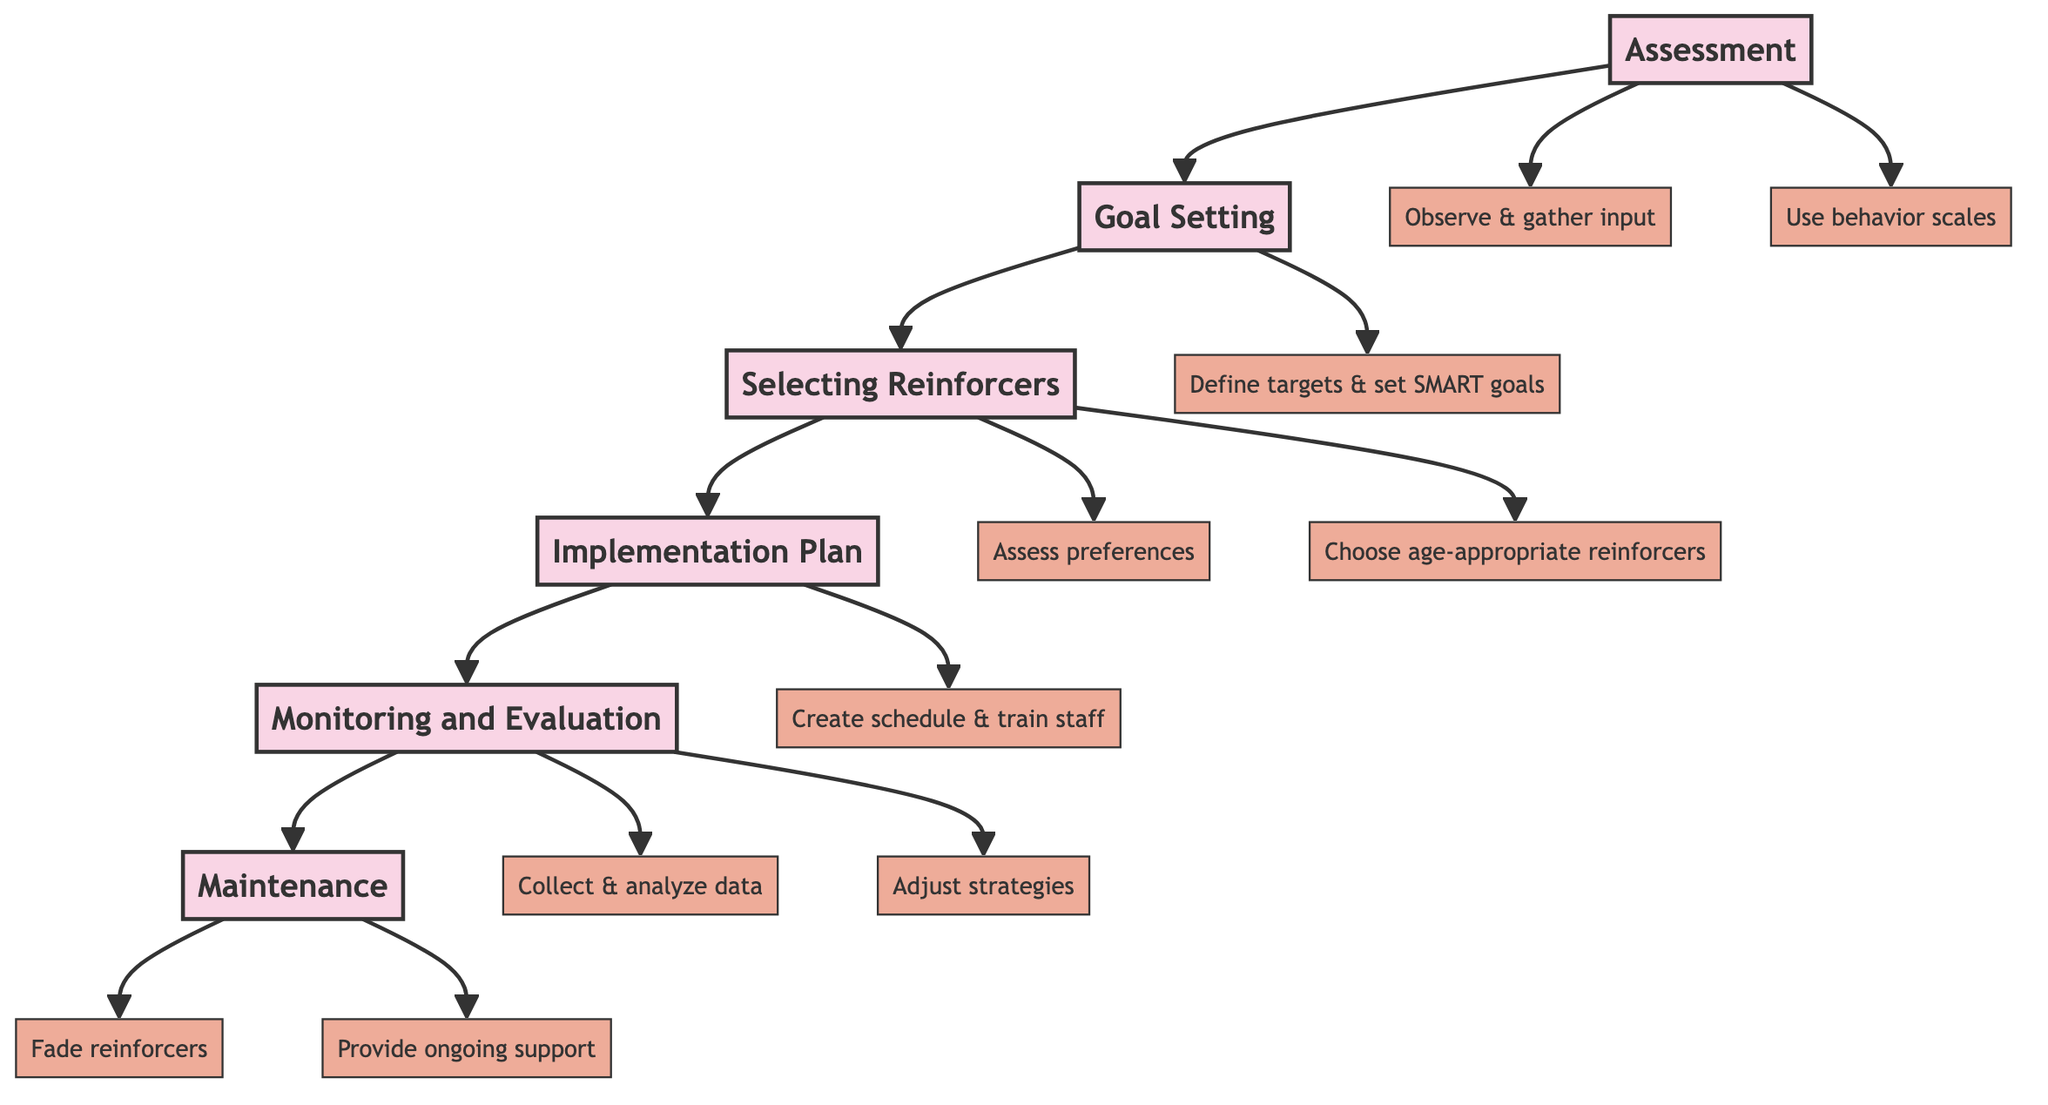What is the first step in the pathway? The diagram indicates that the first step in the sequence is "Assessment." This is the first node from which all subsequent steps branch off.
Answer: Assessment How many steps are there in total? By counting the nodes labeled as steps in the diagram, there are six distinct steps: Assessment, Goal Setting, Selecting Reinforcers, Implementation Plan, Monitoring and Evaluation, and Maintenance.
Answer: Six What is the last step of the clinical pathway? The sequence flows to the last node named "Maintenance," which signifies the endpoint of the pathway.
Answer: Maintenance Which step follows "Selecting Reinforcers"? The diagram shows that "Implementation Plan" is the next step that follows after "Selecting Reinforcers," forming a direct connection in the flow of the pathway.
Answer: Implementation Plan What actions are associated with "Goal Setting"? The key actions related to "Goal Setting" are defining target behaviors, setting short-term and long-term goals, and ensuring that the goals are SMART. This information can be derived from the detailed descriptions linked to that step.
Answer: Define targets, Set goals, Ensure SMART Explain the relationship between “Monitoring and Evaluation” and “Maintenance.” "Monitoring and Evaluation" precedes "Maintenance" in the sequence, indicating that it is essential to first monitor and evaluate behaviors before moving on to the maintenance phase, where sustainability of behavior changes is ensured.
Answer: Monitoring evaluates, Maintenance sustains What are two key actions in the "Selecting Reinforcers" step? The diagram specifies key actions for "Selecting Reinforcers," which are using preference assessments and choosing age-appropriate reinforcers. Both actions are vital for the successful selection of effective reinforcers.
Answer: Assess preferences, Choose age-appropriate What is the purpose of the "Implementation Plan"? The purpose of the "Implementation Plan" is to develop a clear strategy for applying positive reinforcement, which includes creating a reinforcement schedule, training staff, and integrating reinforcement into daily routines.
Answer: Develop a clear plan What happens after the "Implementation Plan"? Following the "Implementation Plan," the next step is "Monitoring and Evaluation," which involves tracking the effectiveness of the implemented strategies and making necessary adjustments as needed.
Answer: Monitoring and Evaluation What is ensured during the "Maintenance" step? The "Maintenance" step ensures sustainability of the positive behavior changes achieved through the previous steps, focusing on fading reinforcers and providing ongoing support to students.
Answer: Sustainability of changes 